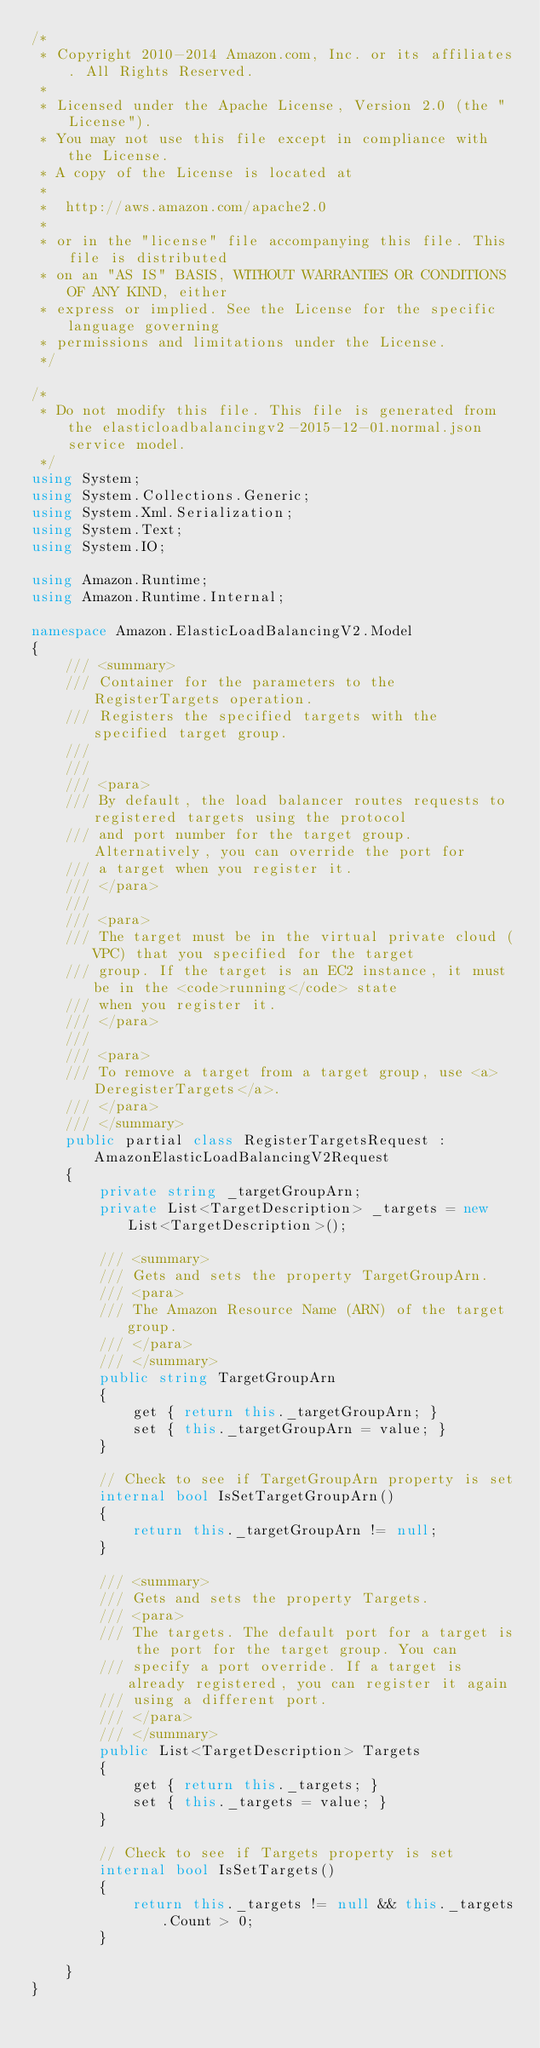Convert code to text. <code><loc_0><loc_0><loc_500><loc_500><_C#_>/*
 * Copyright 2010-2014 Amazon.com, Inc. or its affiliates. All Rights Reserved.
 * 
 * Licensed under the Apache License, Version 2.0 (the "License").
 * You may not use this file except in compliance with the License.
 * A copy of the License is located at
 * 
 *  http://aws.amazon.com/apache2.0
 * 
 * or in the "license" file accompanying this file. This file is distributed
 * on an "AS IS" BASIS, WITHOUT WARRANTIES OR CONDITIONS OF ANY KIND, either
 * express or implied. See the License for the specific language governing
 * permissions and limitations under the License.
 */

/*
 * Do not modify this file. This file is generated from the elasticloadbalancingv2-2015-12-01.normal.json service model.
 */
using System;
using System.Collections.Generic;
using System.Xml.Serialization;
using System.Text;
using System.IO;

using Amazon.Runtime;
using Amazon.Runtime.Internal;

namespace Amazon.ElasticLoadBalancingV2.Model
{
    /// <summary>
    /// Container for the parameters to the RegisterTargets operation.
    /// Registers the specified targets with the specified target group.
    /// 
    ///  
    /// <para>
    /// By default, the load balancer routes requests to registered targets using the protocol
    /// and port number for the target group. Alternatively, you can override the port for
    /// a target when you register it.
    /// </para>
    ///  
    /// <para>
    /// The target must be in the virtual private cloud (VPC) that you specified for the target
    /// group. If the target is an EC2 instance, it must be in the <code>running</code> state
    /// when you register it.
    /// </para>
    ///  
    /// <para>
    /// To remove a target from a target group, use <a>DeregisterTargets</a>.
    /// </para>
    /// </summary>
    public partial class RegisterTargetsRequest : AmazonElasticLoadBalancingV2Request
    {
        private string _targetGroupArn;
        private List<TargetDescription> _targets = new List<TargetDescription>();

        /// <summary>
        /// Gets and sets the property TargetGroupArn. 
        /// <para>
        /// The Amazon Resource Name (ARN) of the target group.
        /// </para>
        /// </summary>
        public string TargetGroupArn
        {
            get { return this._targetGroupArn; }
            set { this._targetGroupArn = value; }
        }

        // Check to see if TargetGroupArn property is set
        internal bool IsSetTargetGroupArn()
        {
            return this._targetGroupArn != null;
        }

        /// <summary>
        /// Gets and sets the property Targets. 
        /// <para>
        /// The targets. The default port for a target is the port for the target group. You can
        /// specify a port override. If a target is already registered, you can register it again
        /// using a different port.
        /// </para>
        /// </summary>
        public List<TargetDescription> Targets
        {
            get { return this._targets; }
            set { this._targets = value; }
        }

        // Check to see if Targets property is set
        internal bool IsSetTargets()
        {
            return this._targets != null && this._targets.Count > 0; 
        }

    }
}</code> 